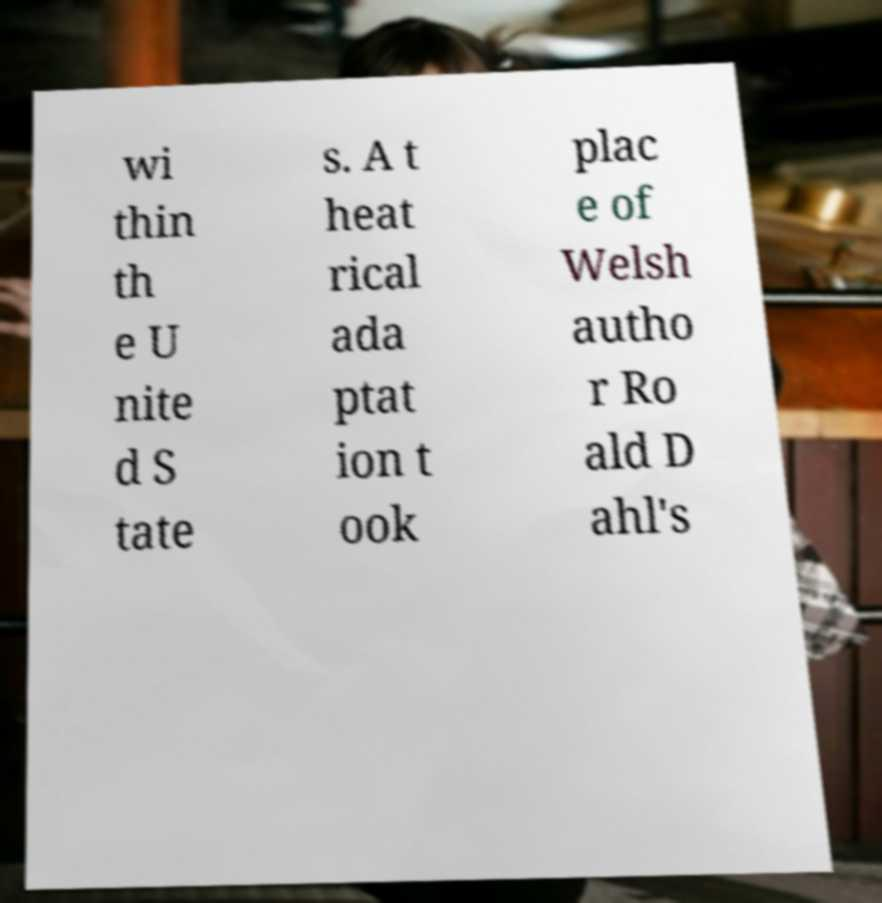I need the written content from this picture converted into text. Can you do that? wi thin th e U nite d S tate s. A t heat rical ada ptat ion t ook plac e of Welsh autho r Ro ald D ahl's 